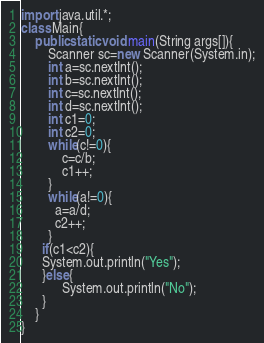<code> <loc_0><loc_0><loc_500><loc_500><_Java_>import java.util.*;
class Main{
	public static void main(String args[]){
    	Scanner sc=new Scanner(System.in);
      	int a=sc.nextInt();
      	int b=sc.nextInt();
      	int c=sc.nextInt();
      	int d=sc.nextInt();
      	int c1=0;
      	int c2=0;
      	while(c!=0){
        	c=c/b;
          	c1++;
        }
      	while(a!=0){
          a=a/d;
          c2++;
        }
      if(c1<c2){
      System.out.println("Yes");
      }else{
            System.out.println("No");
      }
    }
}
</code> 